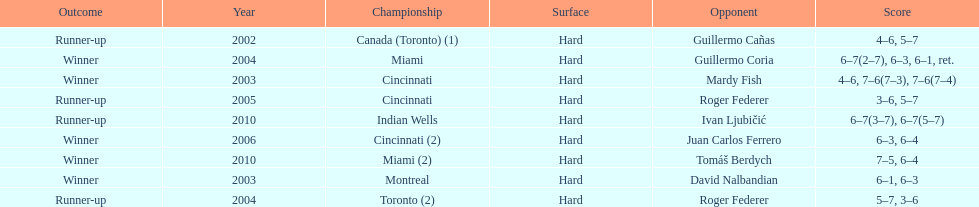Give me the full table as a dictionary. {'header': ['Outcome', 'Year', 'Championship', 'Surface', 'Opponent', 'Score'], 'rows': [['Runner-up', '2002', 'Canada (Toronto) (1)', 'Hard', 'Guillermo Cañas', '4–6, 5–7'], ['Winner', '2004', 'Miami', 'Hard', 'Guillermo Coria', '6–7(2–7), 6–3, 6–1, ret.'], ['Winner', '2003', 'Cincinnati', 'Hard', 'Mardy Fish', '4–6, 7–6(7–3), 7–6(7–4)'], ['Runner-up', '2005', 'Cincinnati', 'Hard', 'Roger Federer', '3–6, 5–7'], ['Runner-up', '2010', 'Indian Wells', 'Hard', 'Ivan Ljubičić', '6–7(3–7), 6–7(5–7)'], ['Winner', '2006', 'Cincinnati (2)', 'Hard', 'Juan Carlos Ferrero', '6–3, 6–4'], ['Winner', '2010', 'Miami (2)', 'Hard', 'Tomáš Berdych', '7–5, 6–4'], ['Winner', '2003', 'Montreal', 'Hard', 'David Nalbandian', '6–1, 6–3'], ['Runner-up', '2004', 'Toronto (2)', 'Hard', 'Roger Federer', '5–7, 3–6']]} What was the highest number of consecutive wins? 3. 